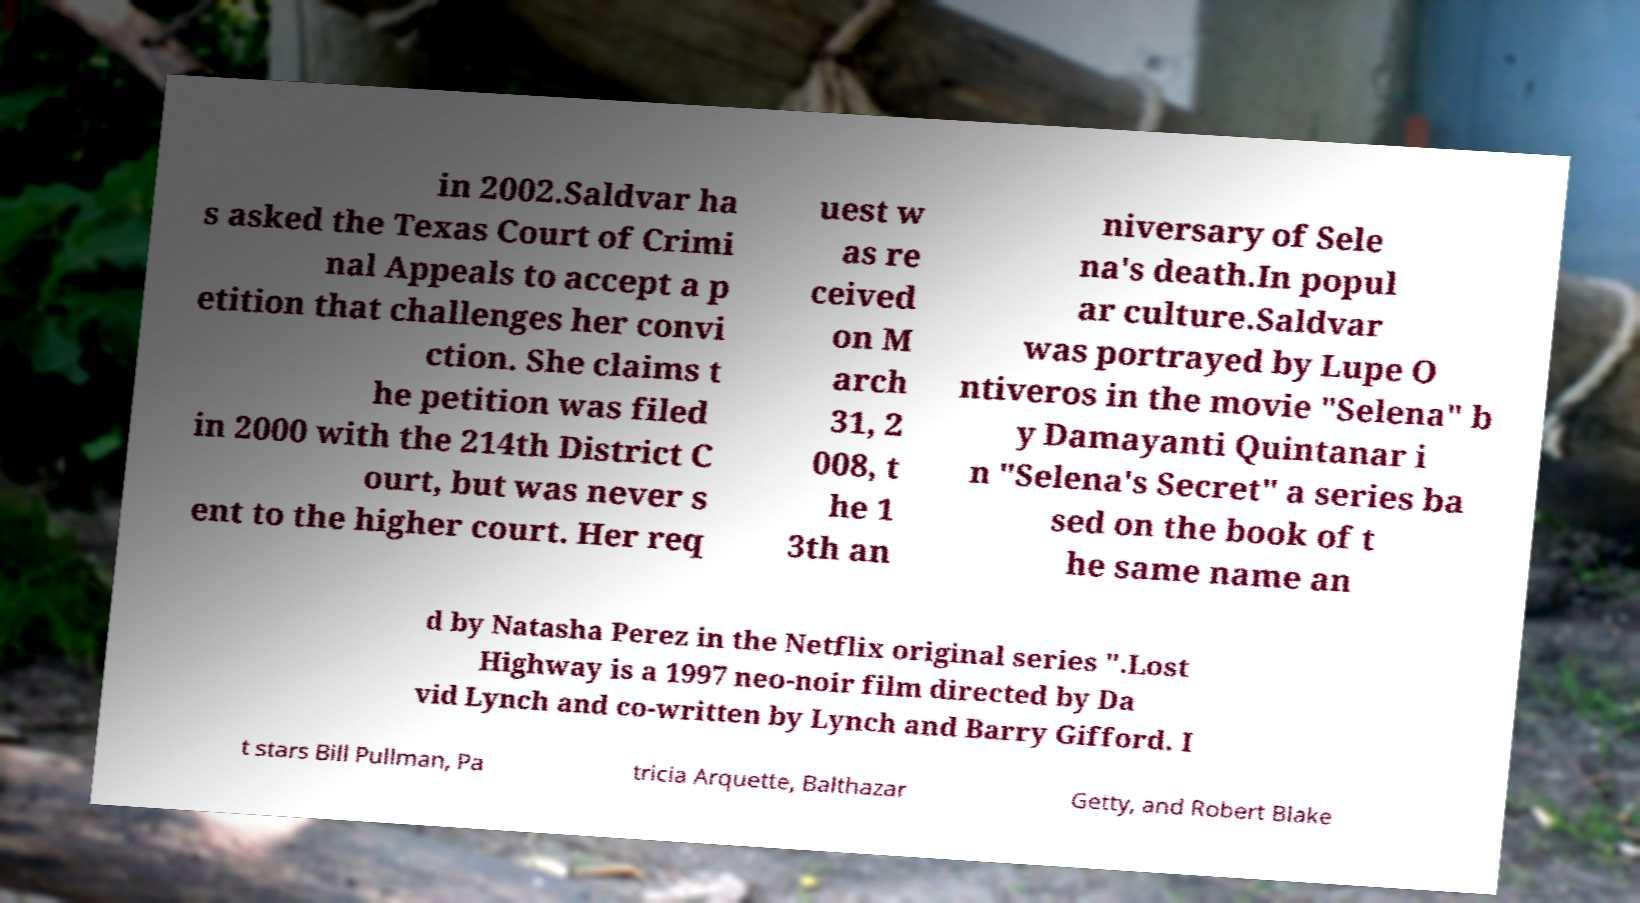For documentation purposes, I need the text within this image transcribed. Could you provide that? in 2002.Saldvar ha s asked the Texas Court of Crimi nal Appeals to accept a p etition that challenges her convi ction. She claims t he petition was filed in 2000 with the 214th District C ourt, but was never s ent to the higher court. Her req uest w as re ceived on M arch 31, 2 008, t he 1 3th an niversary of Sele na's death.In popul ar culture.Saldvar was portrayed by Lupe O ntiveros in the movie "Selena" b y Damayanti Quintanar i n "Selena's Secret" a series ba sed on the book of t he same name an d by Natasha Perez in the Netflix original series ".Lost Highway is a 1997 neo-noir film directed by Da vid Lynch and co-written by Lynch and Barry Gifford. I t stars Bill Pullman, Pa tricia Arquette, Balthazar Getty, and Robert Blake 